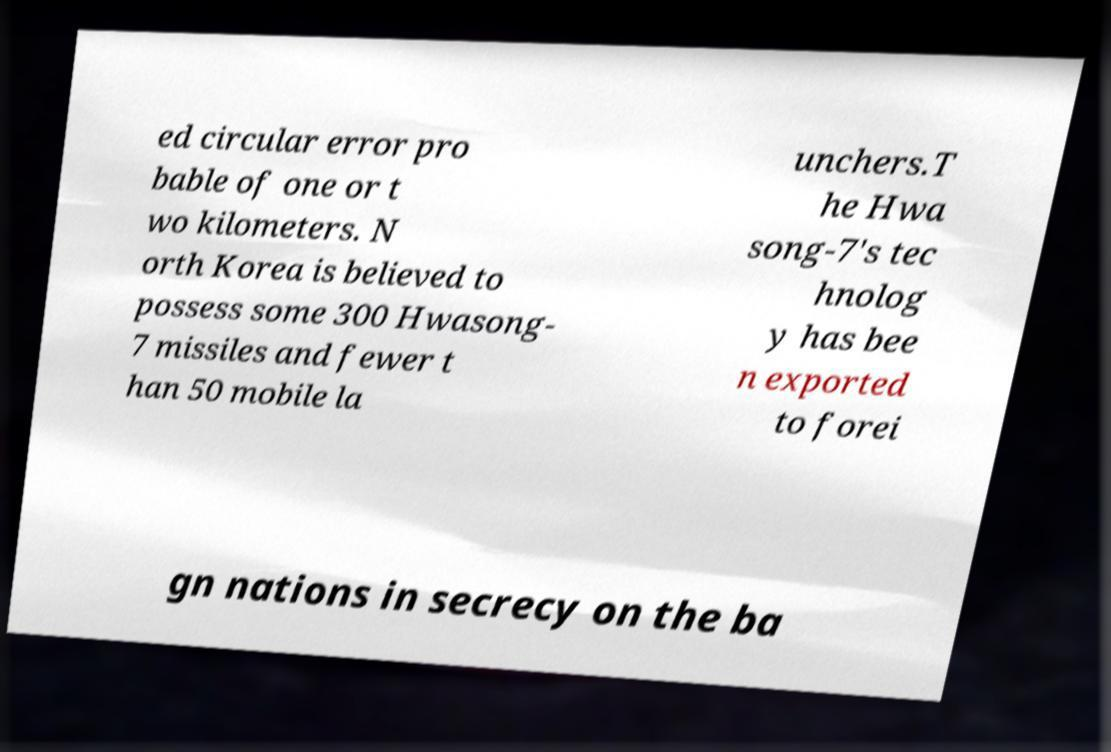Please read and relay the text visible in this image. What does it say? ed circular error pro bable of one or t wo kilometers. N orth Korea is believed to possess some 300 Hwasong- 7 missiles and fewer t han 50 mobile la unchers.T he Hwa song-7's tec hnolog y has bee n exported to forei gn nations in secrecy on the ba 